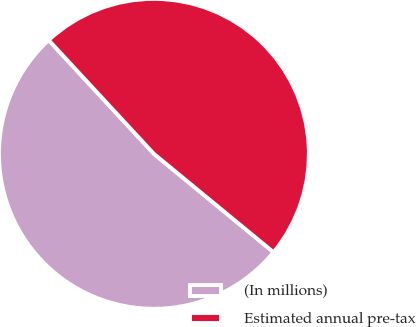<chart> <loc_0><loc_0><loc_500><loc_500><pie_chart><fcel>(In millions)<fcel>Estimated annual pre-tax<nl><fcel>52.16%<fcel>47.84%<nl></chart> 